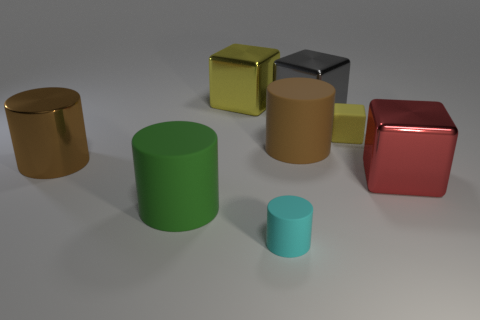What is the shape of the big brown rubber object?
Offer a terse response. Cylinder. Is the size of the yellow block that is left of the gray metallic object the same as the tiny yellow matte cube?
Make the answer very short. No. Is there another object made of the same material as the large yellow thing?
Offer a terse response. Yes. What number of objects are matte things behind the large green thing or large gray metal cubes?
Your answer should be compact. 3. Are there any large red blocks?
Offer a terse response. Yes. What is the shape of the large shiny object that is in front of the gray block and right of the large yellow object?
Keep it short and to the point. Cube. There is a matte cylinder on the left side of the large yellow metal block; what is its size?
Give a very brief answer. Large. There is a cylinder that is in front of the large green rubber thing; is it the same color as the shiny cylinder?
Provide a short and direct response. No. What number of small yellow rubber objects have the same shape as the large gray metallic thing?
Provide a succinct answer. 1. What number of things are shiny cubes that are in front of the large shiny cylinder or cylinders right of the tiny cylinder?
Your answer should be compact. 2. 